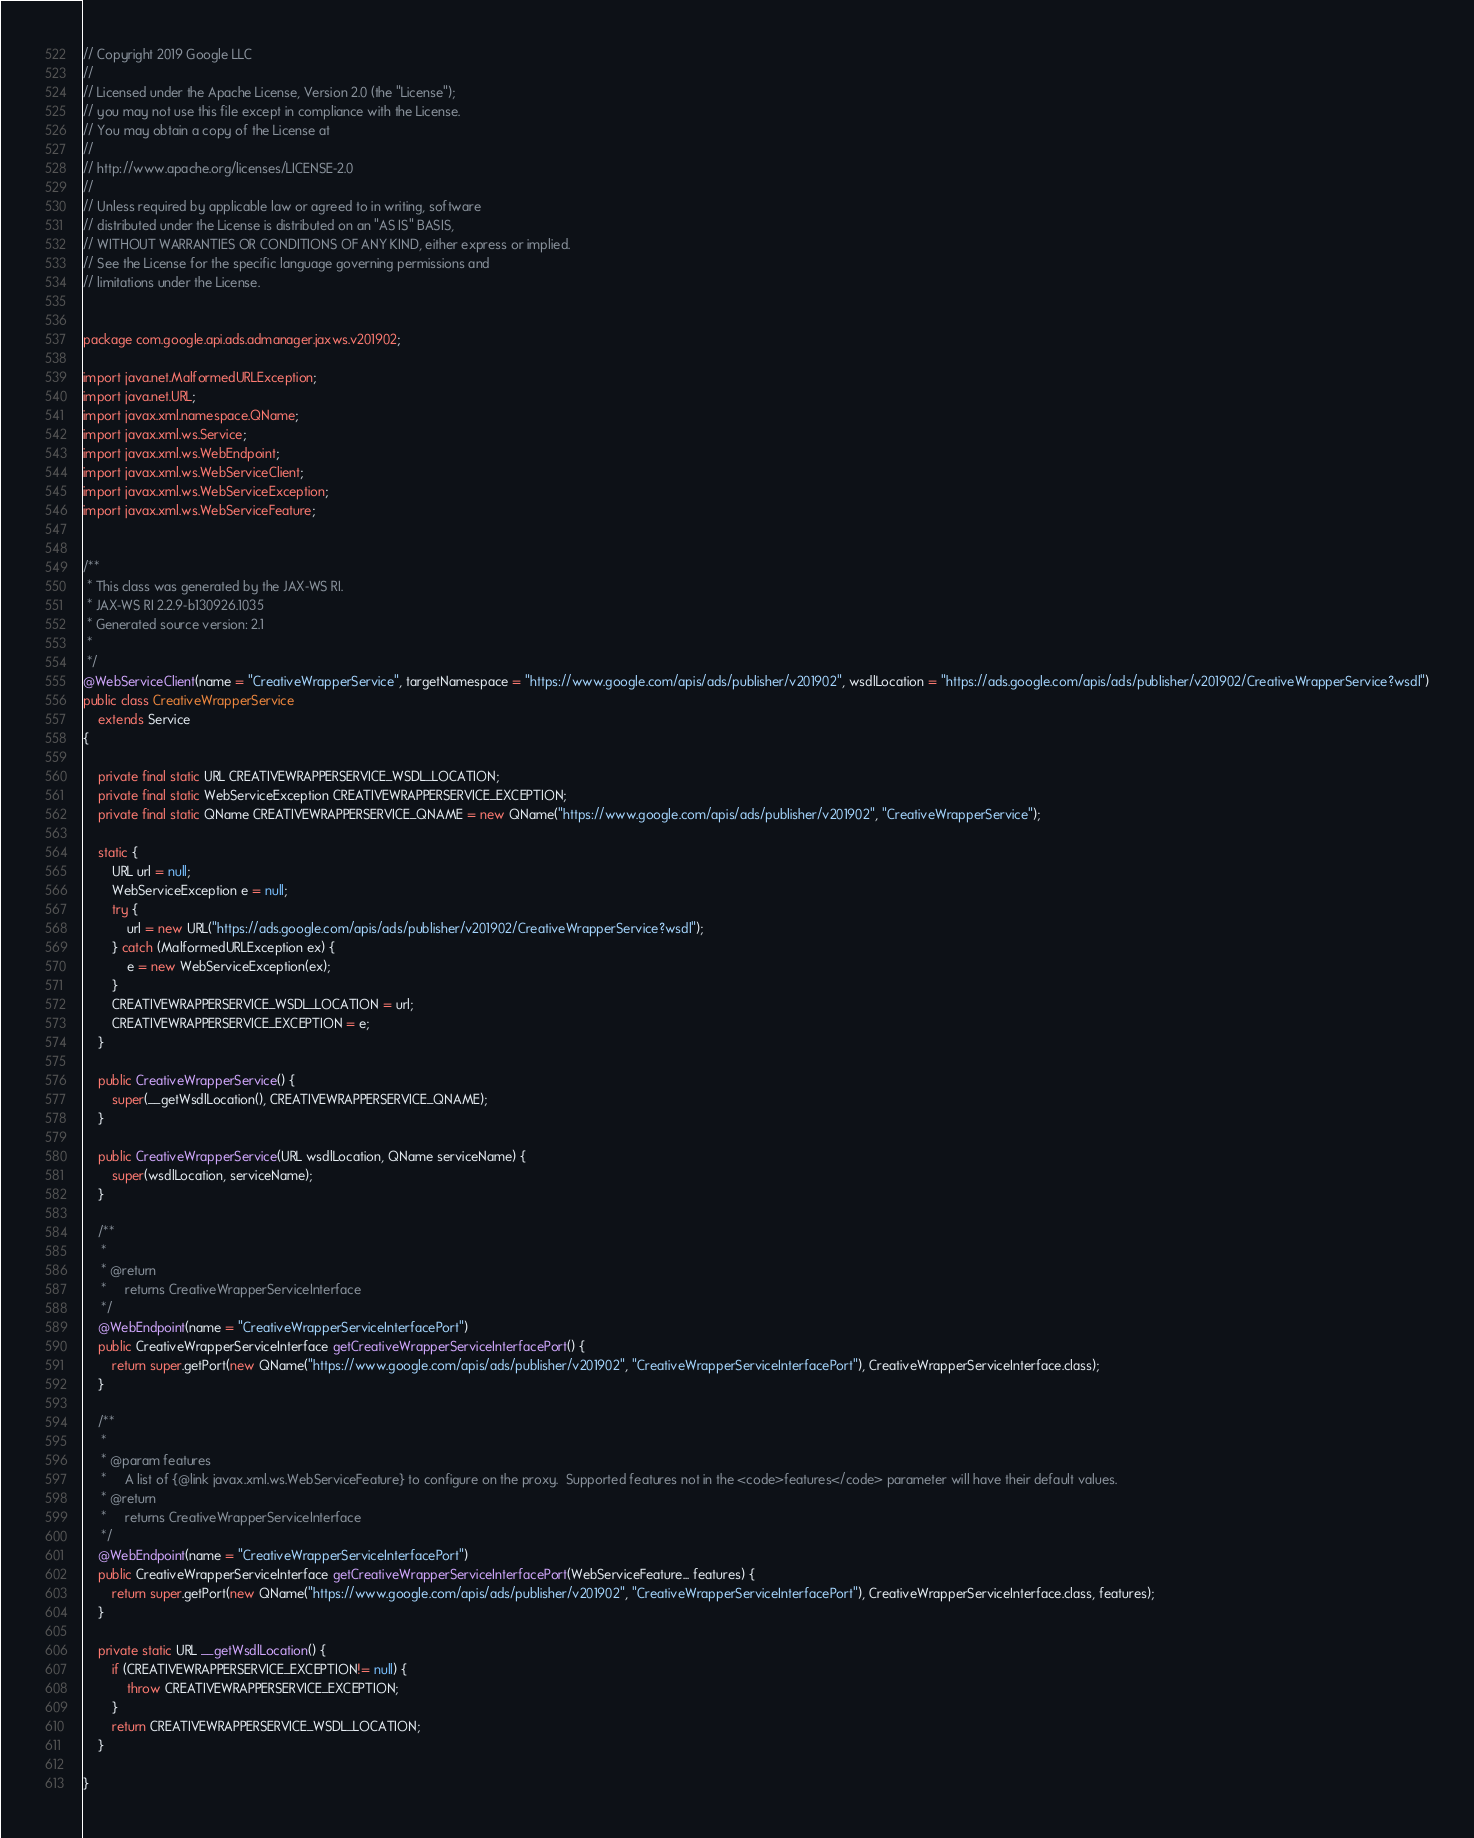<code> <loc_0><loc_0><loc_500><loc_500><_Java_>// Copyright 2019 Google LLC
//
// Licensed under the Apache License, Version 2.0 (the "License");
// you may not use this file except in compliance with the License.
// You may obtain a copy of the License at
//
// http://www.apache.org/licenses/LICENSE-2.0
//
// Unless required by applicable law or agreed to in writing, software
// distributed under the License is distributed on an "AS IS" BASIS,
// WITHOUT WARRANTIES OR CONDITIONS OF ANY KIND, either express or implied.
// See the License for the specific language governing permissions and
// limitations under the License.


package com.google.api.ads.admanager.jaxws.v201902;

import java.net.MalformedURLException;
import java.net.URL;
import javax.xml.namespace.QName;
import javax.xml.ws.Service;
import javax.xml.ws.WebEndpoint;
import javax.xml.ws.WebServiceClient;
import javax.xml.ws.WebServiceException;
import javax.xml.ws.WebServiceFeature;


/**
 * This class was generated by the JAX-WS RI.
 * JAX-WS RI 2.2.9-b130926.1035
 * Generated source version: 2.1
 * 
 */
@WebServiceClient(name = "CreativeWrapperService", targetNamespace = "https://www.google.com/apis/ads/publisher/v201902", wsdlLocation = "https://ads.google.com/apis/ads/publisher/v201902/CreativeWrapperService?wsdl")
public class CreativeWrapperService
    extends Service
{

    private final static URL CREATIVEWRAPPERSERVICE_WSDL_LOCATION;
    private final static WebServiceException CREATIVEWRAPPERSERVICE_EXCEPTION;
    private final static QName CREATIVEWRAPPERSERVICE_QNAME = new QName("https://www.google.com/apis/ads/publisher/v201902", "CreativeWrapperService");

    static {
        URL url = null;
        WebServiceException e = null;
        try {
            url = new URL("https://ads.google.com/apis/ads/publisher/v201902/CreativeWrapperService?wsdl");
        } catch (MalformedURLException ex) {
            e = new WebServiceException(ex);
        }
        CREATIVEWRAPPERSERVICE_WSDL_LOCATION = url;
        CREATIVEWRAPPERSERVICE_EXCEPTION = e;
    }

    public CreativeWrapperService() {
        super(__getWsdlLocation(), CREATIVEWRAPPERSERVICE_QNAME);
    }

    public CreativeWrapperService(URL wsdlLocation, QName serviceName) {
        super(wsdlLocation, serviceName);
    }

    /**
     * 
     * @return
     *     returns CreativeWrapperServiceInterface
     */
    @WebEndpoint(name = "CreativeWrapperServiceInterfacePort")
    public CreativeWrapperServiceInterface getCreativeWrapperServiceInterfacePort() {
        return super.getPort(new QName("https://www.google.com/apis/ads/publisher/v201902", "CreativeWrapperServiceInterfacePort"), CreativeWrapperServiceInterface.class);
    }

    /**
     * 
     * @param features
     *     A list of {@link javax.xml.ws.WebServiceFeature} to configure on the proxy.  Supported features not in the <code>features</code> parameter will have their default values.
     * @return
     *     returns CreativeWrapperServiceInterface
     */
    @WebEndpoint(name = "CreativeWrapperServiceInterfacePort")
    public CreativeWrapperServiceInterface getCreativeWrapperServiceInterfacePort(WebServiceFeature... features) {
        return super.getPort(new QName("https://www.google.com/apis/ads/publisher/v201902", "CreativeWrapperServiceInterfacePort"), CreativeWrapperServiceInterface.class, features);
    }

    private static URL __getWsdlLocation() {
        if (CREATIVEWRAPPERSERVICE_EXCEPTION!= null) {
            throw CREATIVEWRAPPERSERVICE_EXCEPTION;
        }
        return CREATIVEWRAPPERSERVICE_WSDL_LOCATION;
    }

}
</code> 